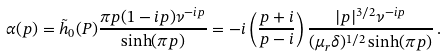Convert formula to latex. <formula><loc_0><loc_0><loc_500><loc_500>\alpha ( p ) = \tilde { h } _ { 0 } ( P ) \frac { \pi p ( 1 - i p ) \nu ^ { - i p } } { \sinh ( \pi p ) } = - i \left ( \frac { p + i } { p - i } \right ) \frac { | p | ^ { 3 / 2 } \nu ^ { - i p } } { ( \mu _ { r } \delta ) ^ { 1 / 2 } \sinh ( \pi p ) } \, .</formula> 